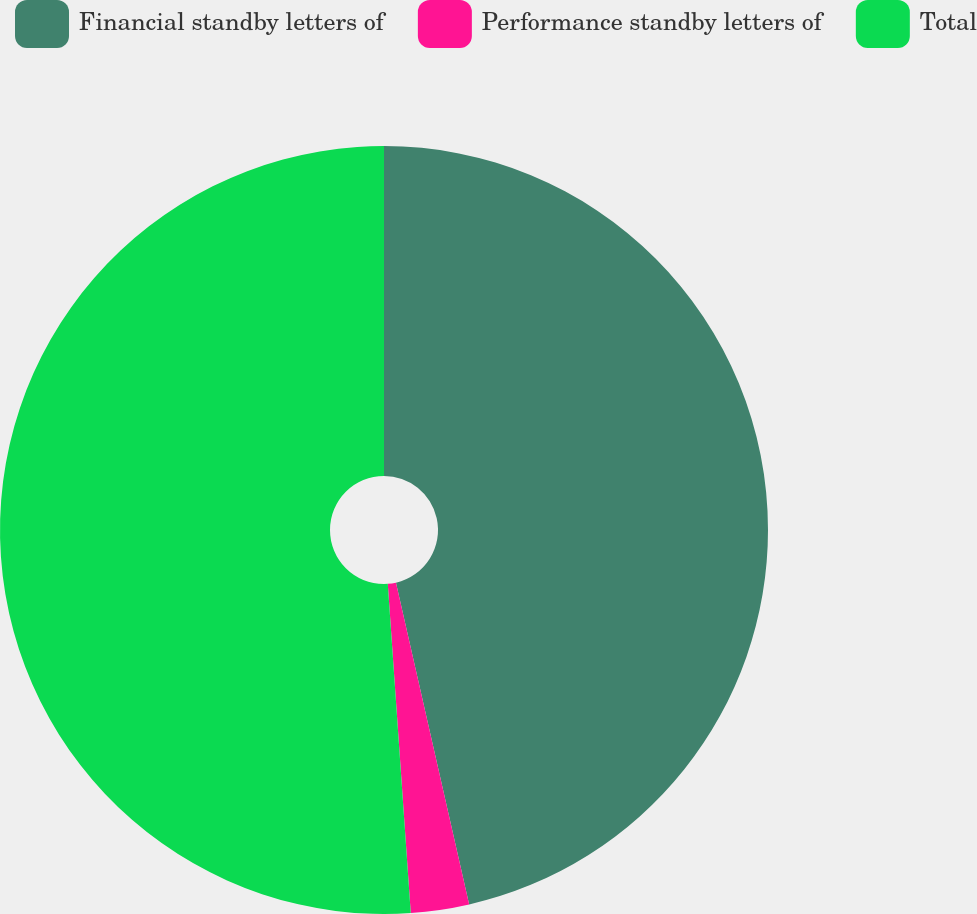<chart> <loc_0><loc_0><loc_500><loc_500><pie_chart><fcel>Financial standby letters of<fcel>Performance standby letters of<fcel>Total<nl><fcel>46.44%<fcel>2.45%<fcel>51.11%<nl></chart> 